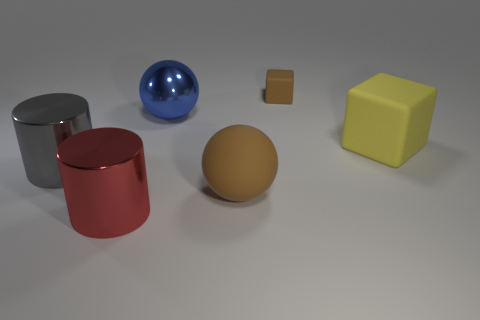Is there any other thing that is the same color as the big cube?
Provide a succinct answer. No. There is a small matte block; are there any red cylinders behind it?
Your answer should be compact. No. Do the tiny rubber block and the large ball in front of the large gray thing have the same color?
Provide a succinct answer. Yes. The object that is behind the ball behind the cylinder behind the brown rubber sphere is what color?
Provide a short and direct response. Brown. Are there any other things that have the same shape as the small rubber thing?
Keep it short and to the point. Yes. What is the color of the other shiny ball that is the same size as the brown ball?
Your response must be concise. Blue. There is a object behind the blue metal thing; what is it made of?
Provide a short and direct response. Rubber. There is a large metal object in front of the gray shiny object; does it have the same shape as the large metallic thing that is left of the red cylinder?
Offer a terse response. Yes. Are there an equal number of big yellow rubber things to the left of the big brown rubber ball and cyan rubber cubes?
Keep it short and to the point. Yes. What number of blue objects are the same material as the big brown object?
Give a very brief answer. 0. 